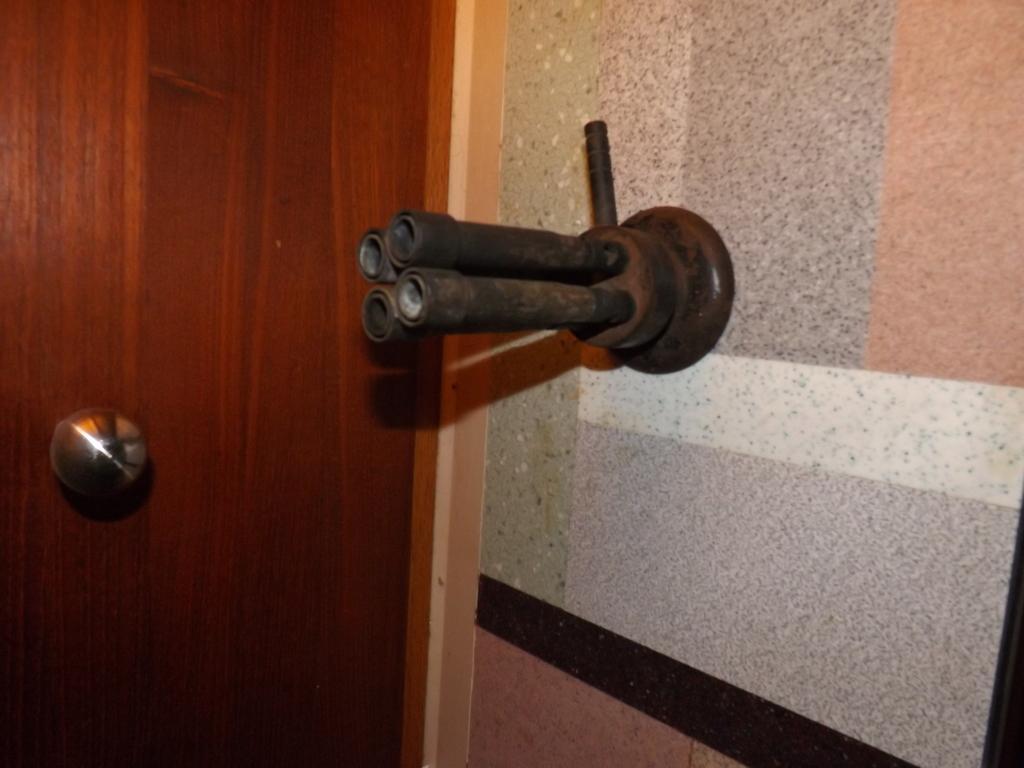Please provide a concise description of this image. In this picture we can see a door on the left side, on the right side there is a wall, we can see door handle here, there are pipes here. 